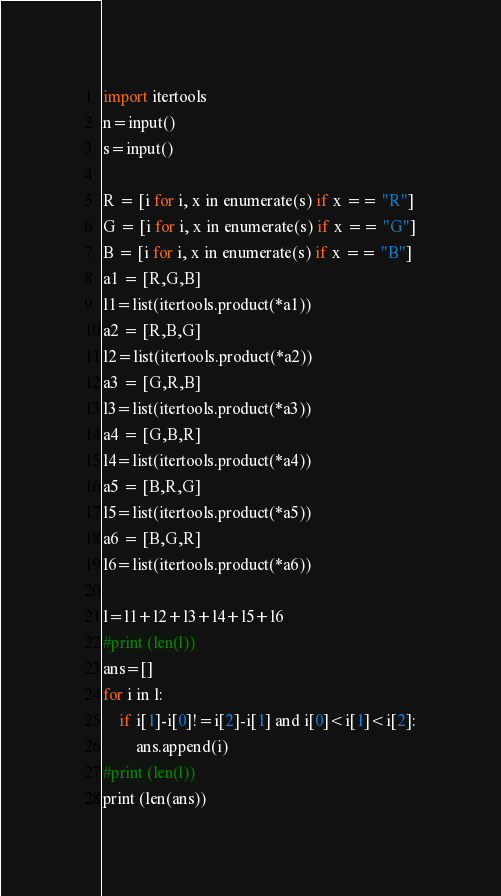Convert code to text. <code><loc_0><loc_0><loc_500><loc_500><_Python_>import itertools
n=input()
s=input()

R = [i for i, x in enumerate(s) if x == "R"]
G = [i for i, x in enumerate(s) if x == "G"]
B = [i for i, x in enumerate(s) if x == "B"]
a1 = [R,G,B]
l1=list(itertools.product(*a1))
a2 = [R,B,G]
l2=list(itertools.product(*a2))
a3 = [G,R,B]
l3=list(itertools.product(*a3))
a4 = [G,B,R]
l4=list(itertools.product(*a4))
a5 = [B,R,G]
l5=list(itertools.product(*a5))
a6 = [B,G,R]
l6=list(itertools.product(*a6))

l=l1+l2+l3+l4+l5+l6
#print (len(l))
ans=[]
for i in l:
    if i[1]-i[0]!=i[2]-i[1] and i[0]<i[1]<i[2]:
        ans.append(i)
#print (len(l))
print (len(ans))</code> 